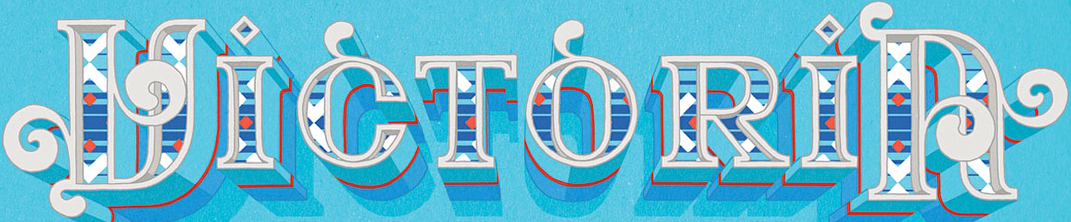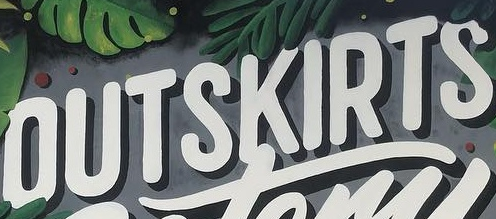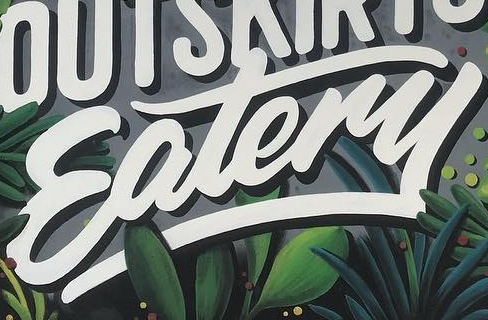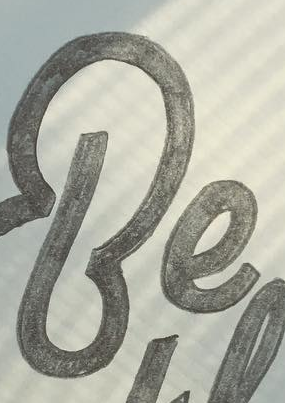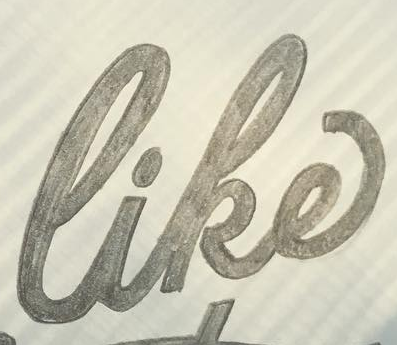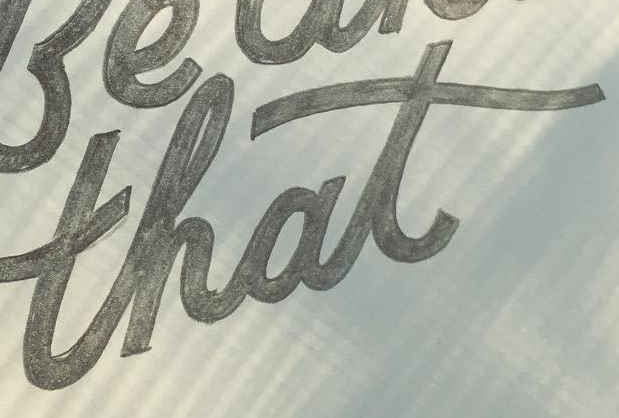Read the text from these images in sequence, separated by a semicolon. VICTORIA; OUTSKIRTS; Eatery; Be; like; that 